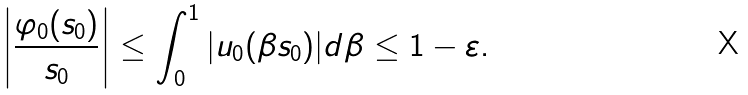Convert formula to latex. <formula><loc_0><loc_0><loc_500><loc_500>\left | \frac { \varphi _ { 0 } ( s _ { 0 } ) } { s _ { 0 } } \right | \leq \int _ { 0 } ^ { 1 } | u _ { 0 } ( \beta s _ { 0 } ) | d \beta \leq 1 - \varepsilon .</formula> 